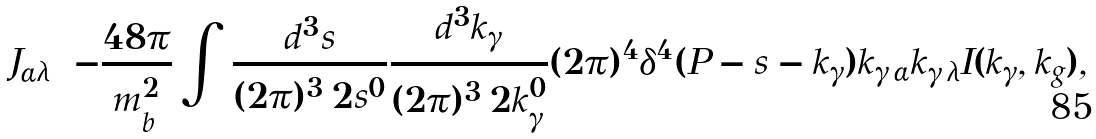<formula> <loc_0><loc_0><loc_500><loc_500>J _ { \alpha \lambda } = - \frac { 4 8 \pi } { m _ { b } ^ { 2 } } \int \frac { d ^ { 3 } s } { ( 2 \pi ) ^ { 3 } \, 2 s ^ { 0 } } \frac { d ^ { 3 } k _ { \gamma } } { ( 2 \pi ) ^ { 3 } \, 2 k _ { \gamma } ^ { 0 } } ( 2 \pi ) ^ { 4 } \delta ^ { 4 } ( P - s - k _ { \gamma } ) k _ { \gamma \, \alpha } k _ { \gamma \, \lambda } I ( k _ { \gamma } , k _ { g } ) ,</formula> 